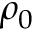<formula> <loc_0><loc_0><loc_500><loc_500>\rho _ { 0 }</formula> 